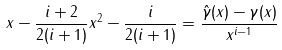Convert formula to latex. <formula><loc_0><loc_0><loc_500><loc_500>x - \frac { i + 2 } { 2 ( i + 1 ) } x ^ { 2 } - \frac { i } { 2 ( i + 1 ) } = \frac { \hat { \gamma } ( x ) - \gamma ( x ) } { x ^ { i - 1 } }</formula> 